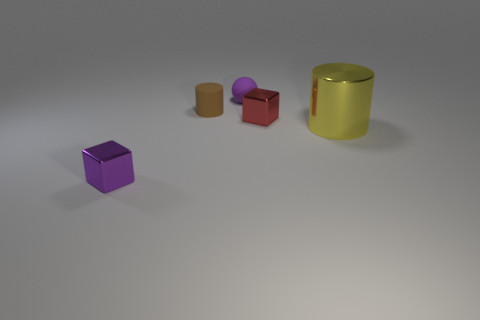What size is the metal cube that is the same color as the small matte ball?
Make the answer very short. Small. The purple block has what size?
Provide a succinct answer. Small. Are there any metallic things behind the tiny metallic object to the right of the small metallic block on the left side of the small brown rubber cylinder?
Keep it short and to the point. No. What number of objects are behind the tiny red cube?
Your answer should be compact. 2. How many objects are the same color as the rubber sphere?
Your answer should be compact. 1. What number of objects are cubes in front of the red metallic thing or purple things that are in front of the large thing?
Provide a succinct answer. 1. Are there more small red shiny blocks than blue objects?
Offer a terse response. Yes. There is a metal cube in front of the big metal cylinder; what is its color?
Your response must be concise. Purple. Does the brown object have the same shape as the purple shiny thing?
Keep it short and to the point. No. What color is the small thing that is both left of the purple ball and behind the yellow shiny thing?
Offer a very short reply. Brown. 